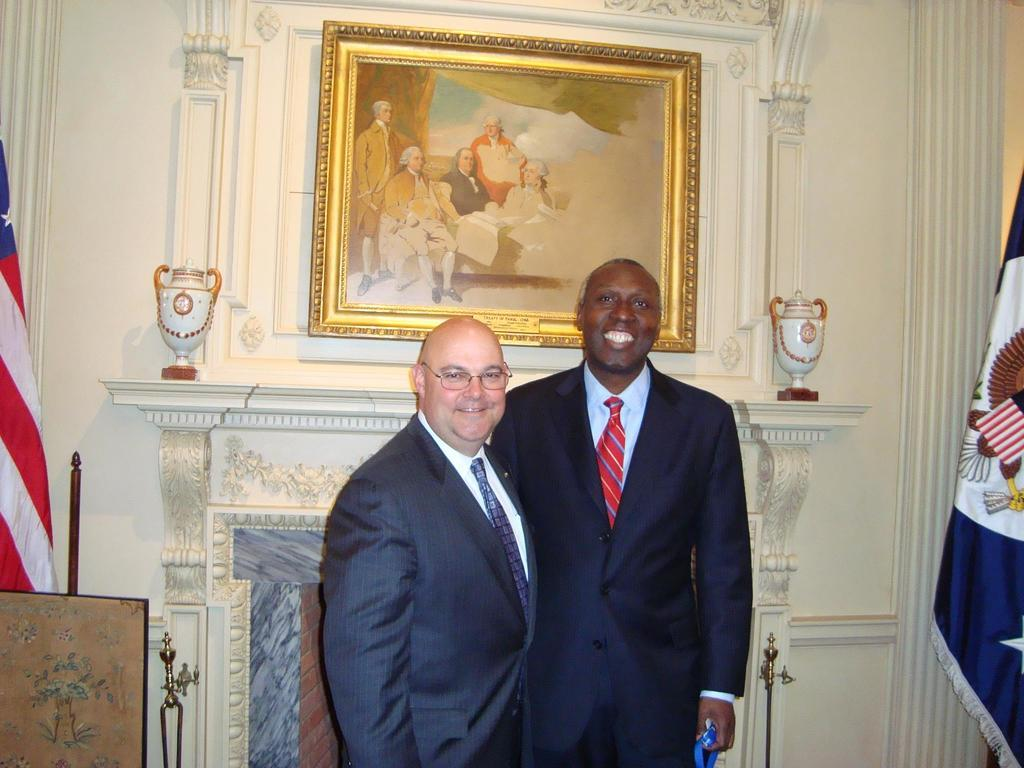What can be seen in the image? There are men standing in the image. What is on the wall in the image? There is a photo frame on the wall. What else is visible in the image? Flags are visible in the image. Can you describe the appearance of one of the men? One man is wearing spectacles. What type of clothing are both men wearing? Both men are wearing coats and ties. What type of needle is the man holding in the image? There is no needle present in the image. What emotion can be seen on the faces of the men in the image? The provided facts do not mention the emotions of the men, so it cannot be determined from the image. 